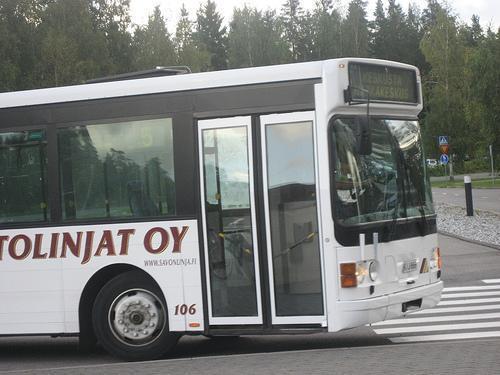How many buses are there?
Give a very brief answer. 1. 